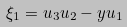<formula> <loc_0><loc_0><loc_500><loc_500>\xi _ { 1 } = u _ { 3 } u _ { 2 } - y u _ { 1 }</formula> 